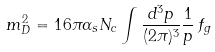<formula> <loc_0><loc_0><loc_500><loc_500>m _ { D } ^ { 2 } = 1 6 \pi \alpha _ { s } N _ { c } \int \frac { d ^ { 3 } p } { ( 2 \pi ) ^ { 3 } } \frac { 1 } { p } \, f _ { g }</formula> 